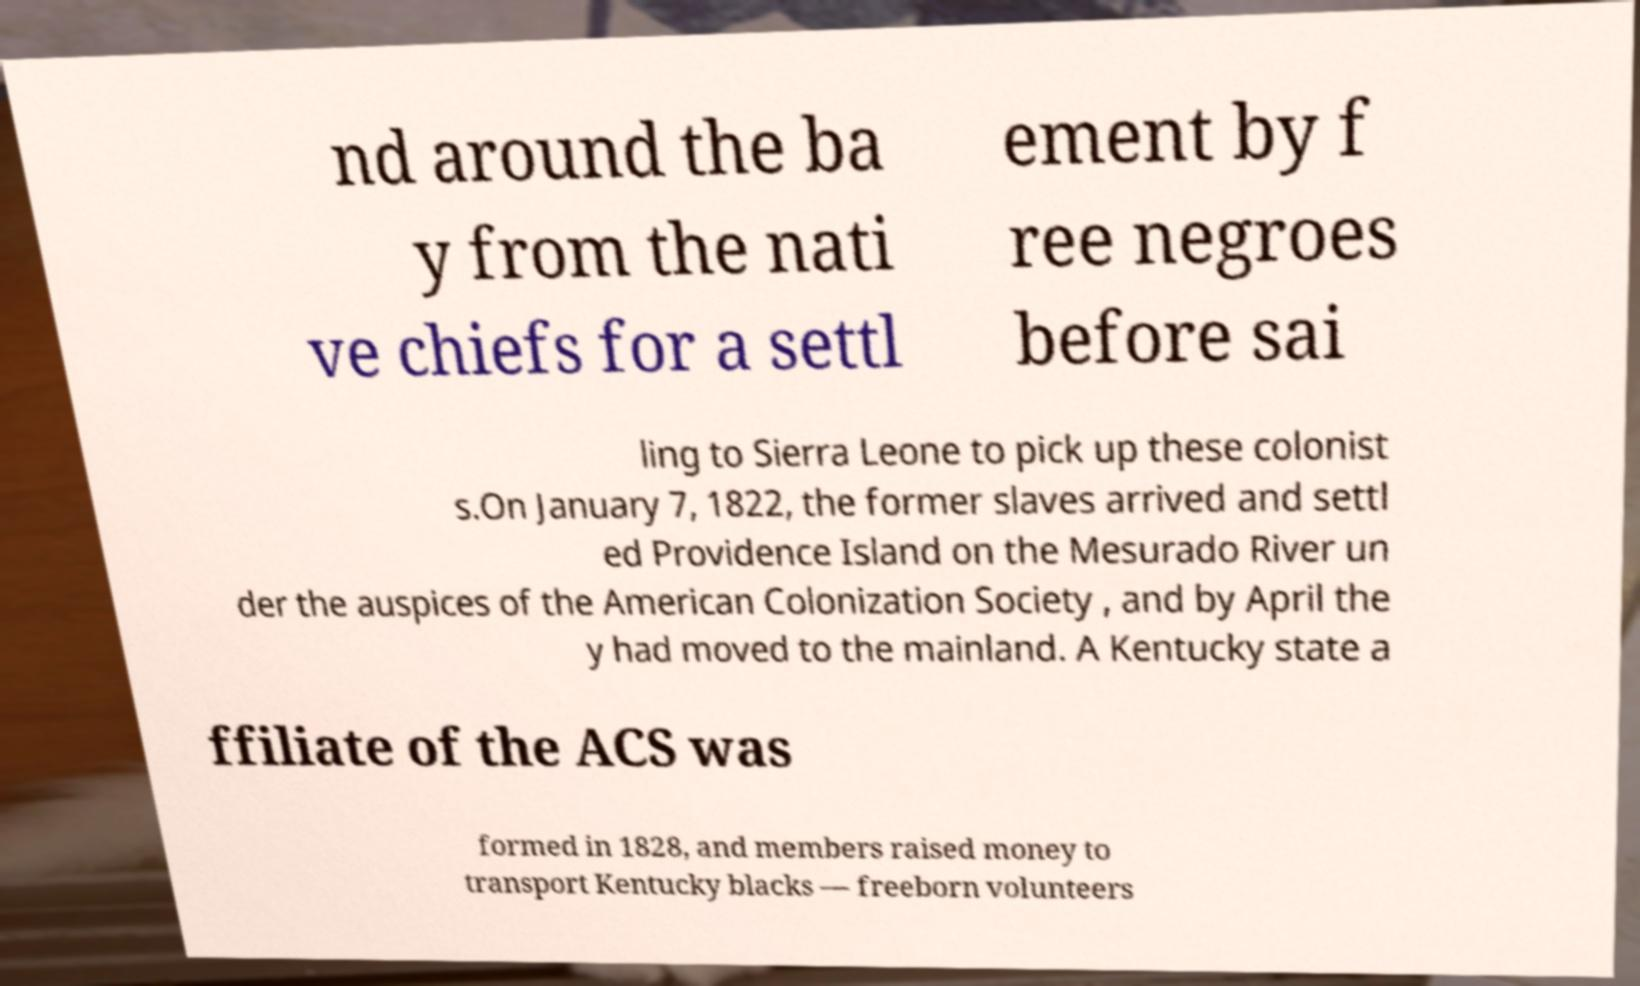Could you extract and type out the text from this image? nd around the ba y from the nati ve chiefs for a settl ement by f ree negroes before sai ling to Sierra Leone to pick up these colonist s.On January 7, 1822, the former slaves arrived and settl ed Providence Island on the Mesurado River un der the auspices of the American Colonization Society , and by April the y had moved to the mainland. A Kentucky state a ffiliate of the ACS was formed in 1828, and members raised money to transport Kentucky blacks — freeborn volunteers 